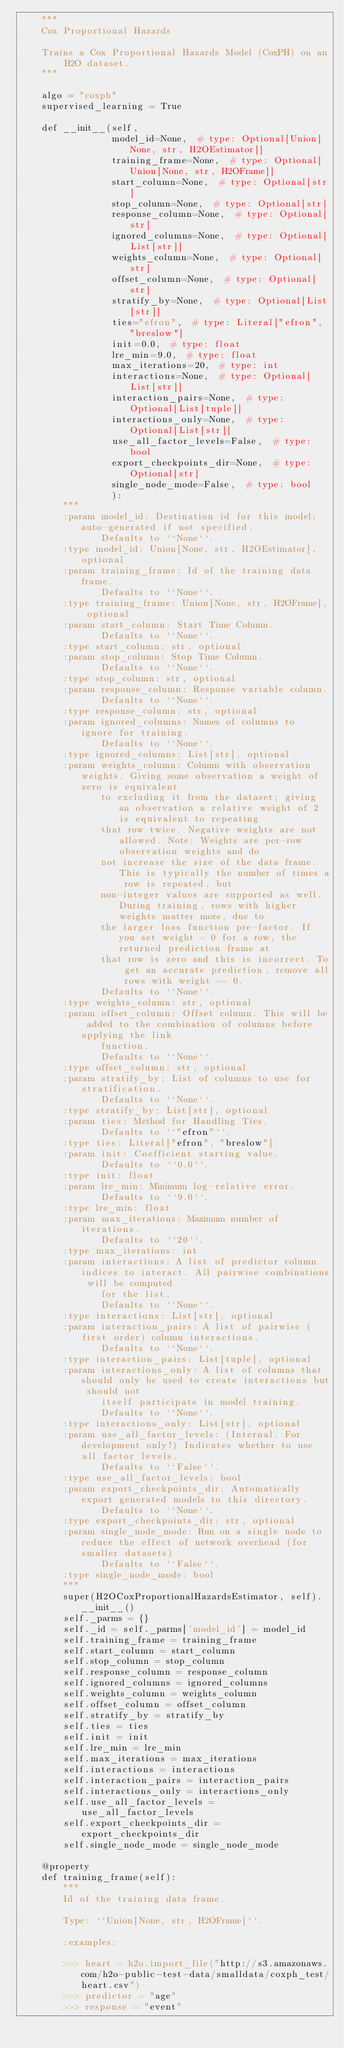Convert code to text. <code><loc_0><loc_0><loc_500><loc_500><_Python_>    """
    Cox Proportional Hazards

    Trains a Cox Proportional Hazards Model (CoxPH) on an H2O dataset.
    """

    algo = "coxph"
    supervised_learning = True

    def __init__(self,
                 model_id=None,  # type: Optional[Union[None, str, H2OEstimator]]
                 training_frame=None,  # type: Optional[Union[None, str, H2OFrame]]
                 start_column=None,  # type: Optional[str]
                 stop_column=None,  # type: Optional[str]
                 response_column=None,  # type: Optional[str]
                 ignored_columns=None,  # type: Optional[List[str]]
                 weights_column=None,  # type: Optional[str]
                 offset_column=None,  # type: Optional[str]
                 stratify_by=None,  # type: Optional[List[str]]
                 ties="efron",  # type: Literal["efron", "breslow"]
                 init=0.0,  # type: float
                 lre_min=9.0,  # type: float
                 max_iterations=20,  # type: int
                 interactions=None,  # type: Optional[List[str]]
                 interaction_pairs=None,  # type: Optional[List[tuple]]
                 interactions_only=None,  # type: Optional[List[str]]
                 use_all_factor_levels=False,  # type: bool
                 export_checkpoints_dir=None,  # type: Optional[str]
                 single_node_mode=False,  # type: bool
                 ):
        """
        :param model_id: Destination id for this model; auto-generated if not specified.
               Defaults to ``None``.
        :type model_id: Union[None, str, H2OEstimator], optional
        :param training_frame: Id of the training data frame.
               Defaults to ``None``.
        :type training_frame: Union[None, str, H2OFrame], optional
        :param start_column: Start Time Column.
               Defaults to ``None``.
        :type start_column: str, optional
        :param stop_column: Stop Time Column.
               Defaults to ``None``.
        :type stop_column: str, optional
        :param response_column: Response variable column.
               Defaults to ``None``.
        :type response_column: str, optional
        :param ignored_columns: Names of columns to ignore for training.
               Defaults to ``None``.
        :type ignored_columns: List[str], optional
        :param weights_column: Column with observation weights. Giving some observation a weight of zero is equivalent
               to excluding it from the dataset; giving an observation a relative weight of 2 is equivalent to repeating
               that row twice. Negative weights are not allowed. Note: Weights are per-row observation weights and do
               not increase the size of the data frame. This is typically the number of times a row is repeated, but
               non-integer values are supported as well. During training, rows with higher weights matter more, due to
               the larger loss function pre-factor. If you set weight = 0 for a row, the returned prediction frame at
               that row is zero and this is incorrect. To get an accurate prediction, remove all rows with weight == 0.
               Defaults to ``None``.
        :type weights_column: str, optional
        :param offset_column: Offset column. This will be added to the combination of columns before applying the link
               function.
               Defaults to ``None``.
        :type offset_column: str, optional
        :param stratify_by: List of columns to use for stratification.
               Defaults to ``None``.
        :type stratify_by: List[str], optional
        :param ties: Method for Handling Ties.
               Defaults to ``"efron"``.
        :type ties: Literal["efron", "breslow"]
        :param init: Coefficient starting value.
               Defaults to ``0.0``.
        :type init: float
        :param lre_min: Minimum log-relative error.
               Defaults to ``9.0``.
        :type lre_min: float
        :param max_iterations: Maximum number of iterations.
               Defaults to ``20``.
        :type max_iterations: int
        :param interactions: A list of predictor column indices to interact. All pairwise combinations will be computed
               for the list.
               Defaults to ``None``.
        :type interactions: List[str], optional
        :param interaction_pairs: A list of pairwise (first order) column interactions.
               Defaults to ``None``.
        :type interaction_pairs: List[tuple], optional
        :param interactions_only: A list of columns that should only be used to create interactions but should not
               itself participate in model training.
               Defaults to ``None``.
        :type interactions_only: List[str], optional
        :param use_all_factor_levels: (Internal. For development only!) Indicates whether to use all factor levels.
               Defaults to ``False``.
        :type use_all_factor_levels: bool
        :param export_checkpoints_dir: Automatically export generated models to this directory.
               Defaults to ``None``.
        :type export_checkpoints_dir: str, optional
        :param single_node_mode: Run on a single node to reduce the effect of network overhead (for smaller datasets)
               Defaults to ``False``.
        :type single_node_mode: bool
        """
        super(H2OCoxProportionalHazardsEstimator, self).__init__()
        self._parms = {}
        self._id = self._parms['model_id'] = model_id
        self.training_frame = training_frame
        self.start_column = start_column
        self.stop_column = stop_column
        self.response_column = response_column
        self.ignored_columns = ignored_columns
        self.weights_column = weights_column
        self.offset_column = offset_column
        self.stratify_by = stratify_by
        self.ties = ties
        self.init = init
        self.lre_min = lre_min
        self.max_iterations = max_iterations
        self.interactions = interactions
        self.interaction_pairs = interaction_pairs
        self.interactions_only = interactions_only
        self.use_all_factor_levels = use_all_factor_levels
        self.export_checkpoints_dir = export_checkpoints_dir
        self.single_node_mode = single_node_mode

    @property
    def training_frame(self):
        """
        Id of the training data frame.

        Type: ``Union[None, str, H2OFrame]``.

        :examples:

        >>> heart = h2o.import_file("http://s3.amazonaws.com/h2o-public-test-data/smalldata/coxph_test/heart.csv")
        >>> predictor = "age"
        >>> response = "event"</code> 